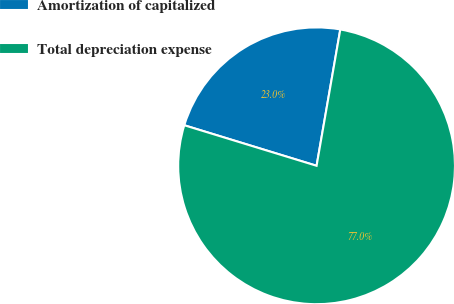Convert chart. <chart><loc_0><loc_0><loc_500><loc_500><pie_chart><fcel>Amortization of capitalized<fcel>Total depreciation expense<nl><fcel>23.01%<fcel>76.99%<nl></chart> 